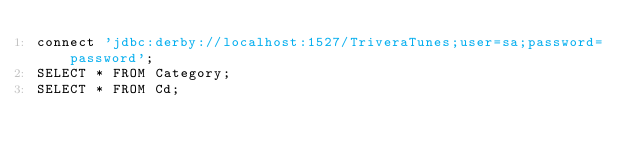Convert code to text. <code><loc_0><loc_0><loc_500><loc_500><_SQL_>connect 'jdbc:derby://localhost:1527/TriveraTunes;user=sa;password=password';
SELECT * FROM Category;
SELECT * FROM Cd; 
</code> 